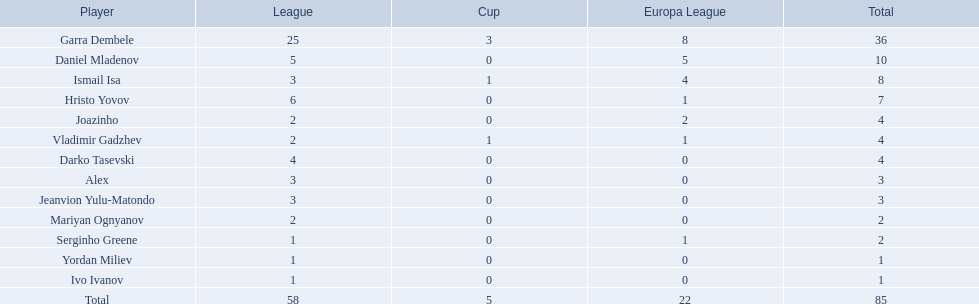Who are all the members? Garra Dembele, Daniel Mladenov, Ismail Isa, Hristo Yovov, Joazinho, Vladimir Gadzhev, Darko Tasevski, Alex, Jeanvion Yulu-Matondo, Mariyan Ognyanov, Serginho Greene, Yordan Miliev, Ivo Ivanov. And which association is each member part of? 25, 5, 3, 6, 2, 2, 4, 3, 3, 2, 1, 1, 1. In addition to vladimir gadzhev and joazinho, which other individual is in league 2? Mariyan Ognyanov. 